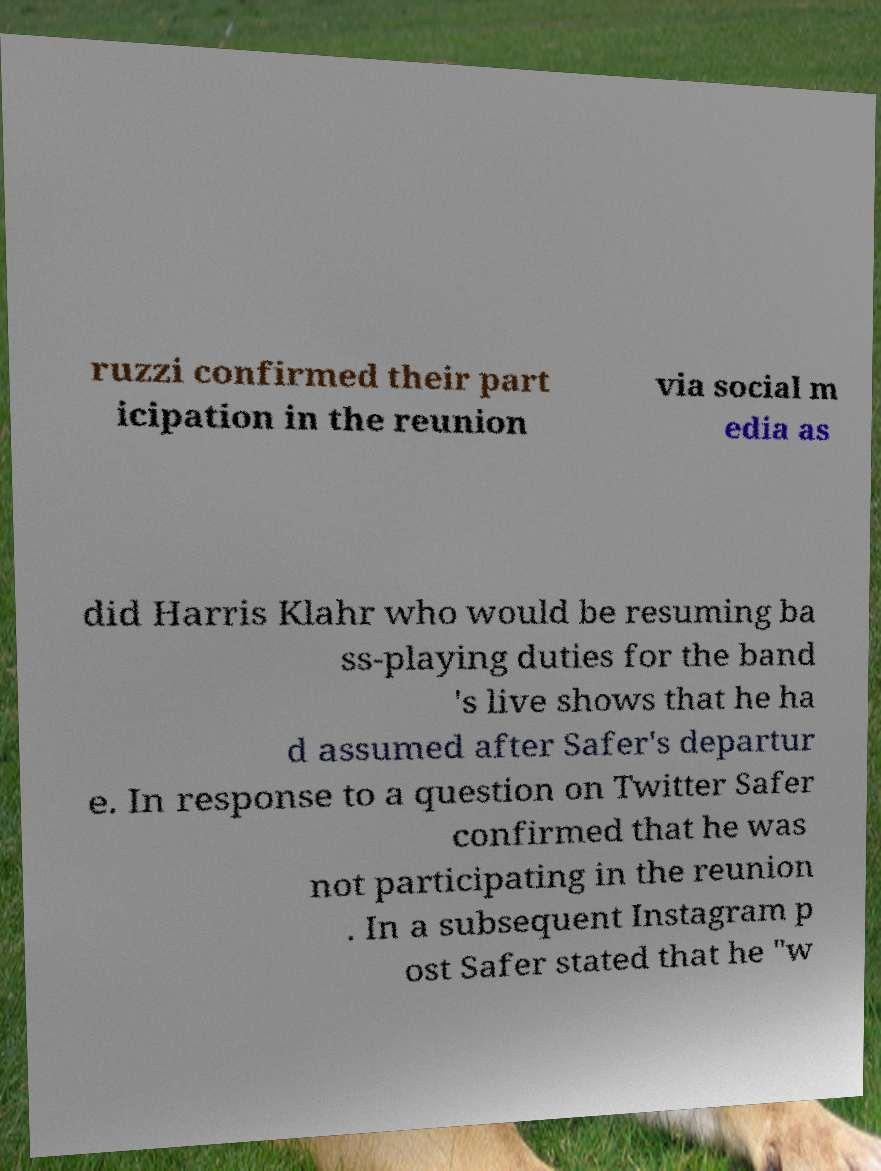For documentation purposes, I need the text within this image transcribed. Could you provide that? ruzzi confirmed their part icipation in the reunion via social m edia as did Harris Klahr who would be resuming ba ss-playing duties for the band 's live shows that he ha d assumed after Safer's departur e. In response to a question on Twitter Safer confirmed that he was not participating in the reunion . In a subsequent Instagram p ost Safer stated that he "w 